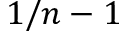<formula> <loc_0><loc_0><loc_500><loc_500>1 / n - 1</formula> 